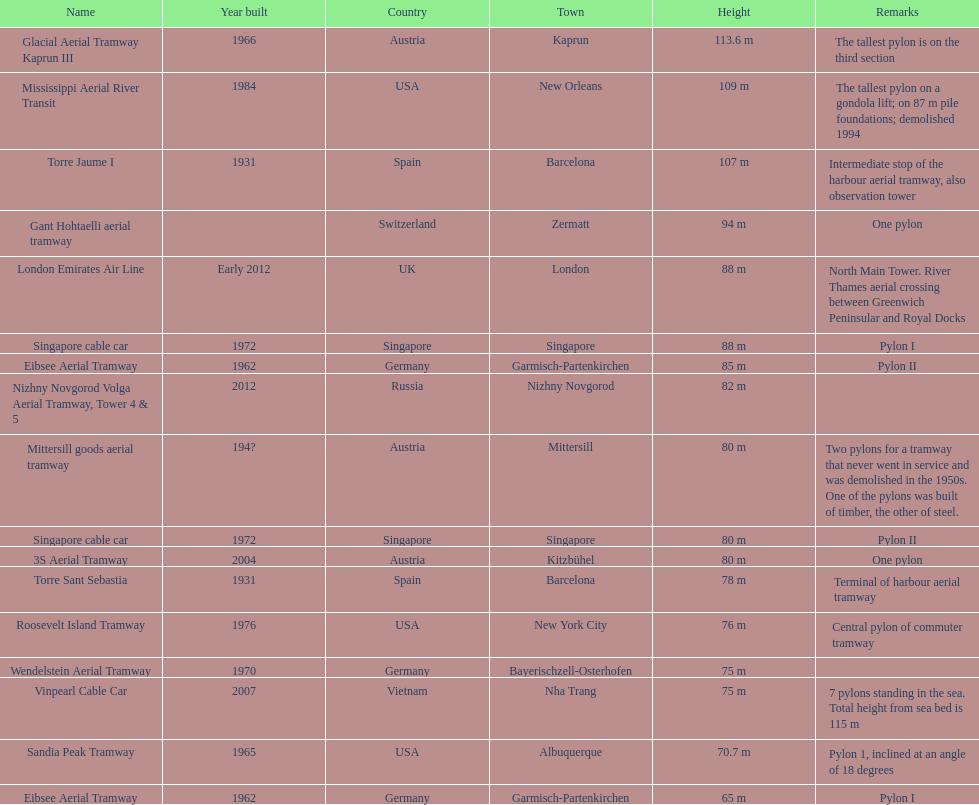Write the full table. {'header': ['Name', 'Year built', 'Country', 'Town', 'Height', 'Remarks'], 'rows': [['Glacial Aerial Tramway Kaprun III', '1966', 'Austria', 'Kaprun', '113.6 m', 'The tallest pylon is on the third section'], ['Mississippi Aerial River Transit', '1984', 'USA', 'New Orleans', '109 m', 'The tallest pylon on a gondola lift; on 87 m pile foundations; demolished 1994'], ['Torre Jaume I', '1931', 'Spain', 'Barcelona', '107 m', 'Intermediate stop of the harbour aerial tramway, also observation tower'], ['Gant Hohtaelli aerial tramway', '', 'Switzerland', 'Zermatt', '94 m', 'One pylon'], ['London Emirates Air Line', 'Early 2012', 'UK', 'London', '88 m', 'North Main Tower. River Thames aerial crossing between Greenwich Peninsular and Royal Docks'], ['Singapore cable car', '1972', 'Singapore', 'Singapore', '88 m', 'Pylon I'], ['Eibsee Aerial Tramway', '1962', 'Germany', 'Garmisch-Partenkirchen', '85 m', 'Pylon II'], ['Nizhny Novgorod Volga Aerial Tramway, Tower 4 & 5', '2012', 'Russia', 'Nizhny Novgorod', '82 m', ''], ['Mittersill goods aerial tramway', '194?', 'Austria', 'Mittersill', '80 m', 'Two pylons for a tramway that never went in service and was demolished in the 1950s. One of the pylons was built of timber, the other of steel.'], ['Singapore cable car', '1972', 'Singapore', 'Singapore', '80 m', 'Pylon II'], ['3S Aerial Tramway', '2004', 'Austria', 'Kitzbühel', '80 m', 'One pylon'], ['Torre Sant Sebastia', '1931', 'Spain', 'Barcelona', '78 m', 'Terminal of harbour aerial tramway'], ['Roosevelt Island Tramway', '1976', 'USA', 'New York City', '76 m', 'Central pylon of commuter tramway'], ['Wendelstein Aerial Tramway', '1970', 'Germany', 'Bayerischzell-Osterhofen', '75 m', ''], ['Vinpearl Cable Car', '2007', 'Vietnam', 'Nha Trang', '75 m', '7 pylons standing in the sea. Total height from sea bed is 115 m'], ['Sandia Peak Tramway', '1965', 'USA', 'Albuquerque', '70.7 m', 'Pylon 1, inclined at an angle of 18 degrees'], ['Eibsee Aerial Tramway', '1962', 'Germany', 'Garmisch-Partenkirchen', '65 m', 'Pylon I']]} How many metres is the tallest pylon? 113.6 m. 